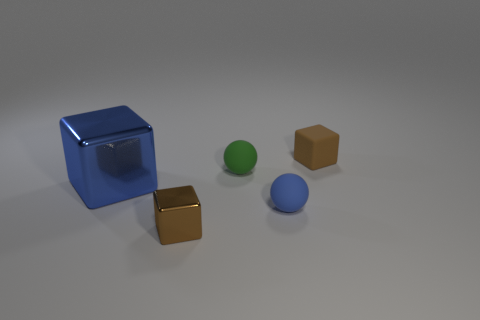There is a tiny cube on the right side of the small metallic thing; what color is it?
Offer a terse response. Brown. Does the blue rubber thing on the left side of the brown matte cube have the same shape as the brown object that is in front of the large blue shiny thing?
Provide a succinct answer. No. Is there a brown matte thing that has the same size as the green matte thing?
Ensure brevity in your answer.  Yes. There is a brown cube that is in front of the blue shiny block; what is it made of?
Your answer should be compact. Metal. Does the brown object that is behind the big blue shiny cube have the same material as the big cube?
Your answer should be very brief. No. Are any tiny shiny objects visible?
Your answer should be very brief. Yes. What color is the cube that is made of the same material as the blue sphere?
Your answer should be very brief. Brown. What color is the small cube on the left side of the tiny brown object that is to the right of the blue object in front of the blue metal block?
Provide a short and direct response. Brown. There is a green sphere; is it the same size as the brown object in front of the blue matte ball?
Your answer should be very brief. Yes. What number of objects are tiny matte objects behind the green matte object or spheres in front of the green rubber sphere?
Offer a terse response. 2. 